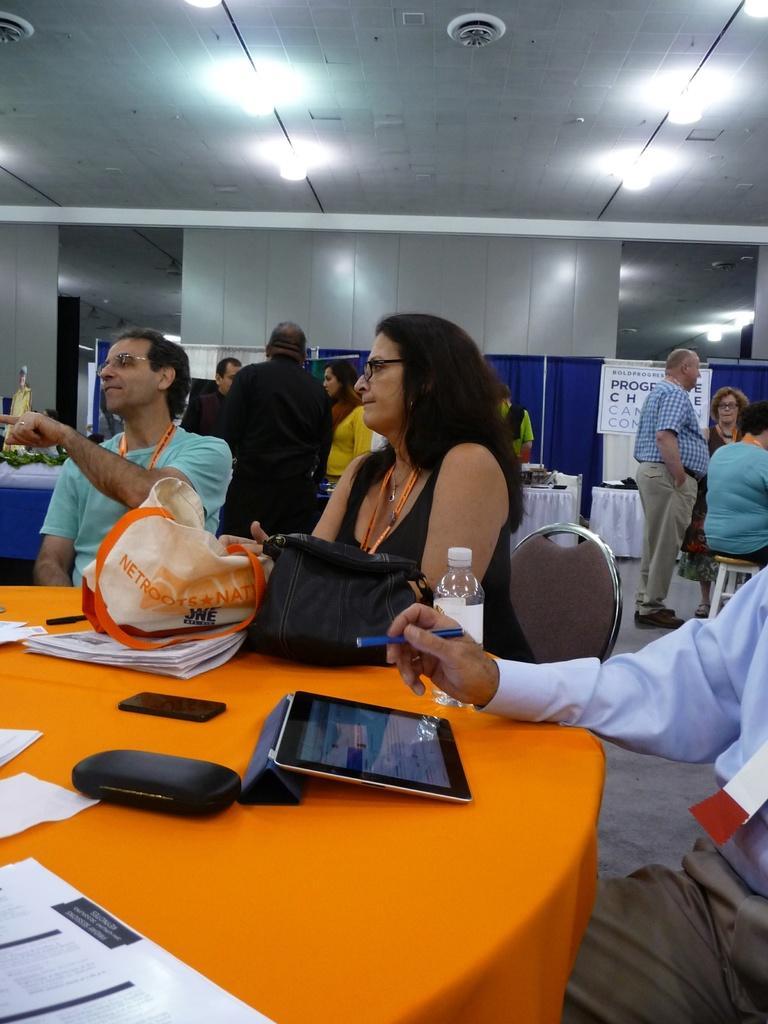Please provide a concise description of this image. The image is inside the room. In the image there are three people sitting on chair in front of a table, on table we can see a cloth which is in orange color,tablet,box,mobile,paper,bags,water bottle. On right side we can see a man standing and background we can also see some hoardings on top there is a roof with few lights. 